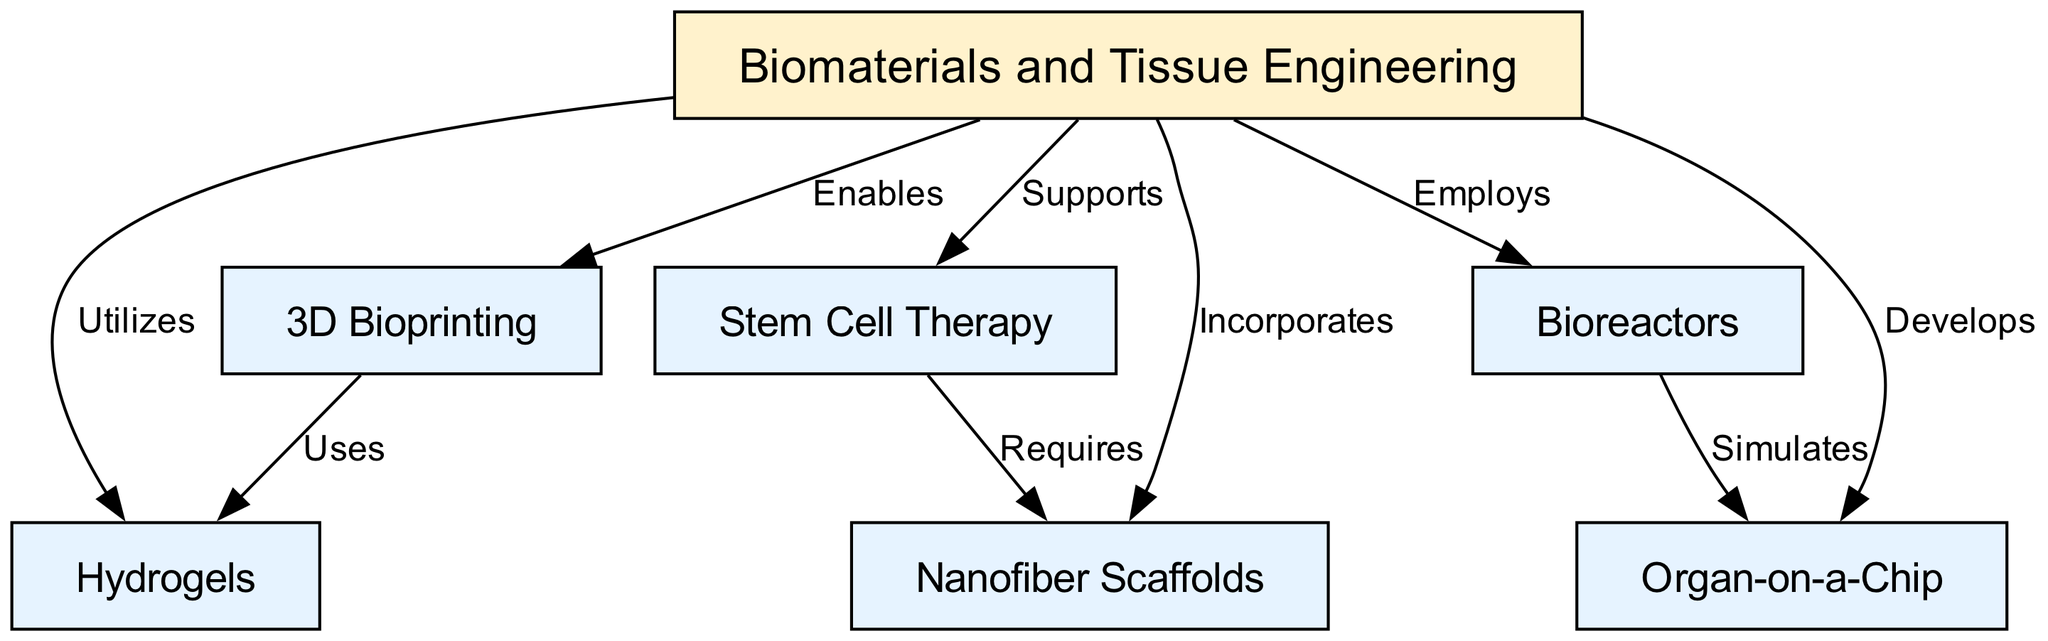What is the main topic of the concept map? The main topic is found at the center of the diagram, where the node labeled "Biomaterials and Tissue Engineering" is located. This node connects to various advancements and technologies in the field.
Answer: Biomaterials and Tissue Engineering How many nodes are present in the diagram? To find the total number of nodes, count each node listed in the data structure. There are seven nodes in total.
Answer: 7 What type of technology is "3D Bioprinting" associated with? The relationship is indicated by the edge labeled "Enables," which shows that "3D Bioprinting" is a capability that supports the main topic of "Biomaterials and Tissue Engineering."
Answer: Enables Which node requires "Nanofiber Scaffolds"? The edge between these nodes labeled "Requires" indicates that "Stem Cell Therapy" depends on or needs "Nanofiber Scaffolds" for its application in regenerative medicine.
Answer: Stem Cell Therapy What two nodes are connected by the edge labeled "Simulates"? This edge connects "Bioreactors" and "Organ-on-a-Chip," indicating that one simulates the functions and processes of the other.
Answer: Bioreactors and Organ-on-a-Chip How does "Hydrogels" contribute to "Biomaterials and Tissue Engineering"? The relationship is represented by the edge labeled "Utilizes," suggesting that "Biomaterials and Tissue Engineering" makes use of "Hydrogels" as a resource or component.
Answer: Utilizes What advancements does "3D Bioprinting" use? According to the edge labeled "Uses," "3D Bioprinting" uses "Hydrogels," demonstrating a specific application within the field of tissue engineering.
Answer: Hydrogels What technology does "Bioreactors" employ? The relationship established by the edge labeled "Employs" suggests that "Bioreactors" are utilized as a critical tool or mechanism within "Biomaterials and Tissue Engineering."
Answer: Employs 